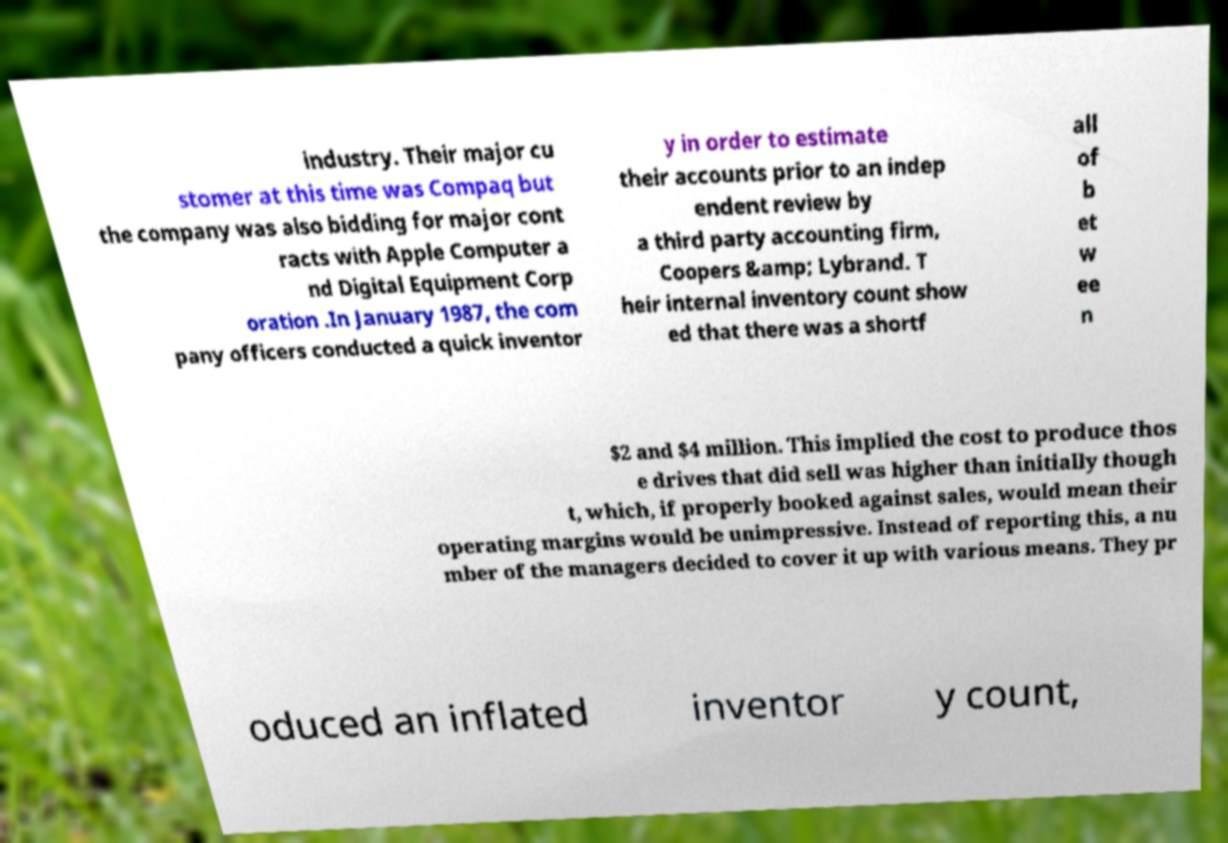Could you assist in decoding the text presented in this image and type it out clearly? industry. Their major cu stomer at this time was Compaq but the company was also bidding for major cont racts with Apple Computer a nd Digital Equipment Corp oration .In January 1987, the com pany officers conducted a quick inventor y in order to estimate their accounts prior to an indep endent review by a third party accounting firm, Coopers &amp; Lybrand. T heir internal inventory count show ed that there was a shortf all of b et w ee n $2 and $4 million. This implied the cost to produce thos e drives that did sell was higher than initially though t, which, if properly booked against sales, would mean their operating margins would be unimpressive. Instead of reporting this, a nu mber of the managers decided to cover it up with various means. They pr oduced an inflated inventor y count, 